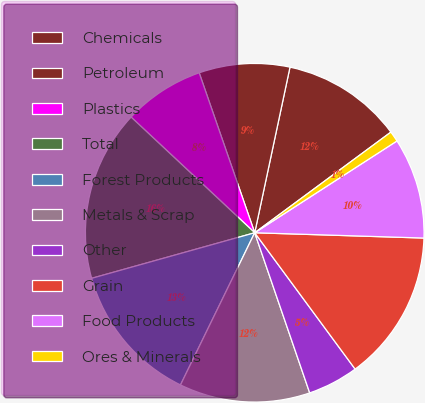<chart> <loc_0><loc_0><loc_500><loc_500><pie_chart><fcel>Chemicals<fcel>Petroleum<fcel>Plastics<fcel>Total<fcel>Forest Products<fcel>Metals & Scrap<fcel>Other<fcel>Grain<fcel>Food Products<fcel>Ores & Minerals<nl><fcel>11.53%<fcel>8.66%<fcel>7.71%<fcel>16.31%<fcel>13.44%<fcel>12.49%<fcel>4.84%<fcel>14.4%<fcel>9.62%<fcel>1.01%<nl></chart> 